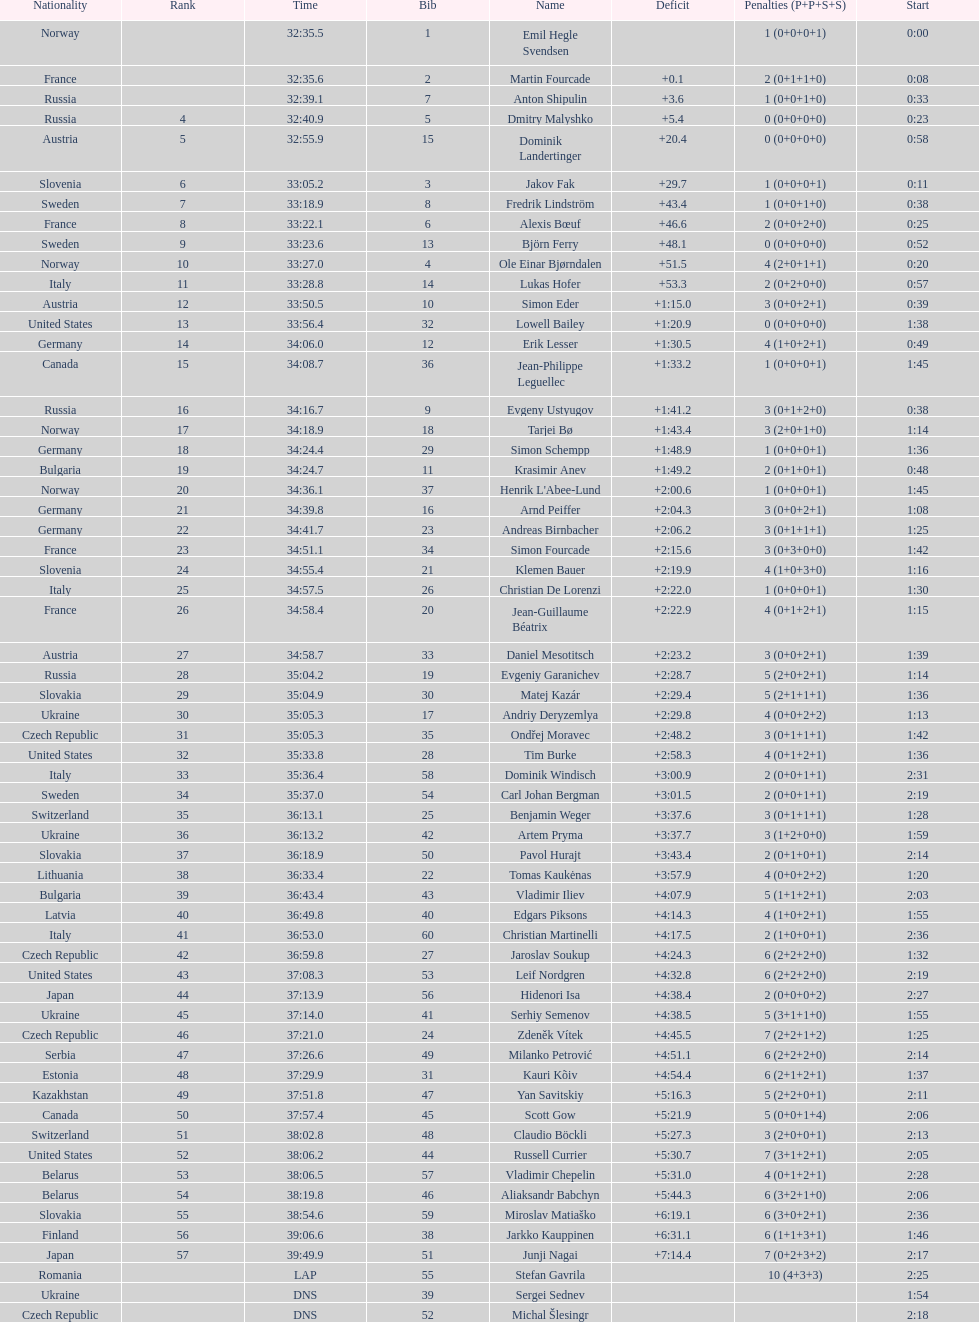What is the total number of participants between norway and france? 7. 